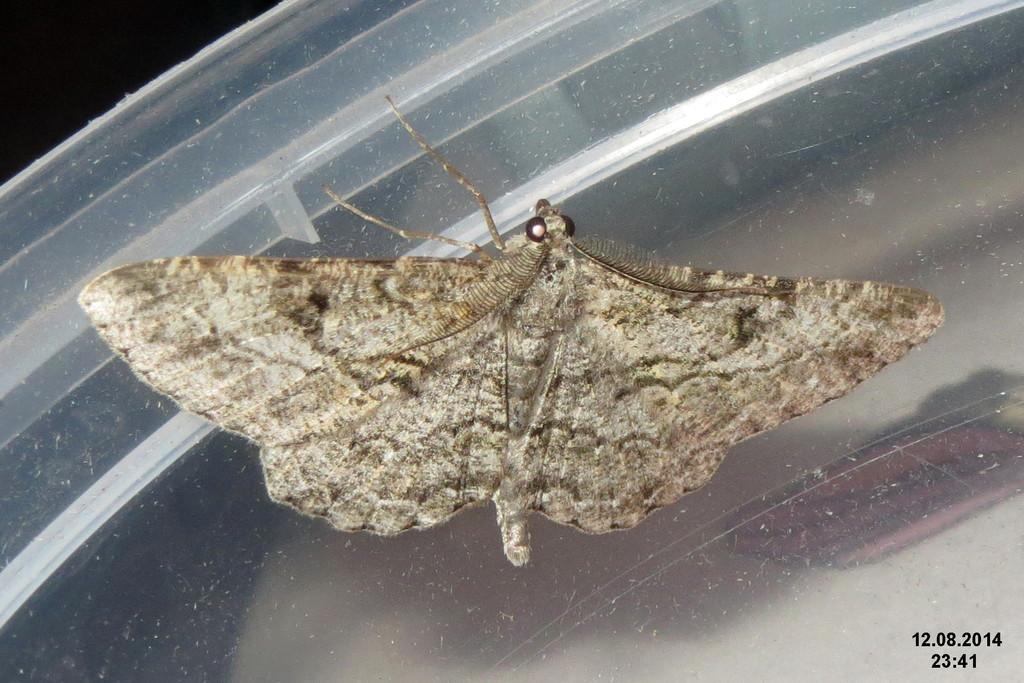Can you describe this image briefly? In this picture we can see a moth in the middle, there are some numbers at the right bottom, we can see a dark background. 